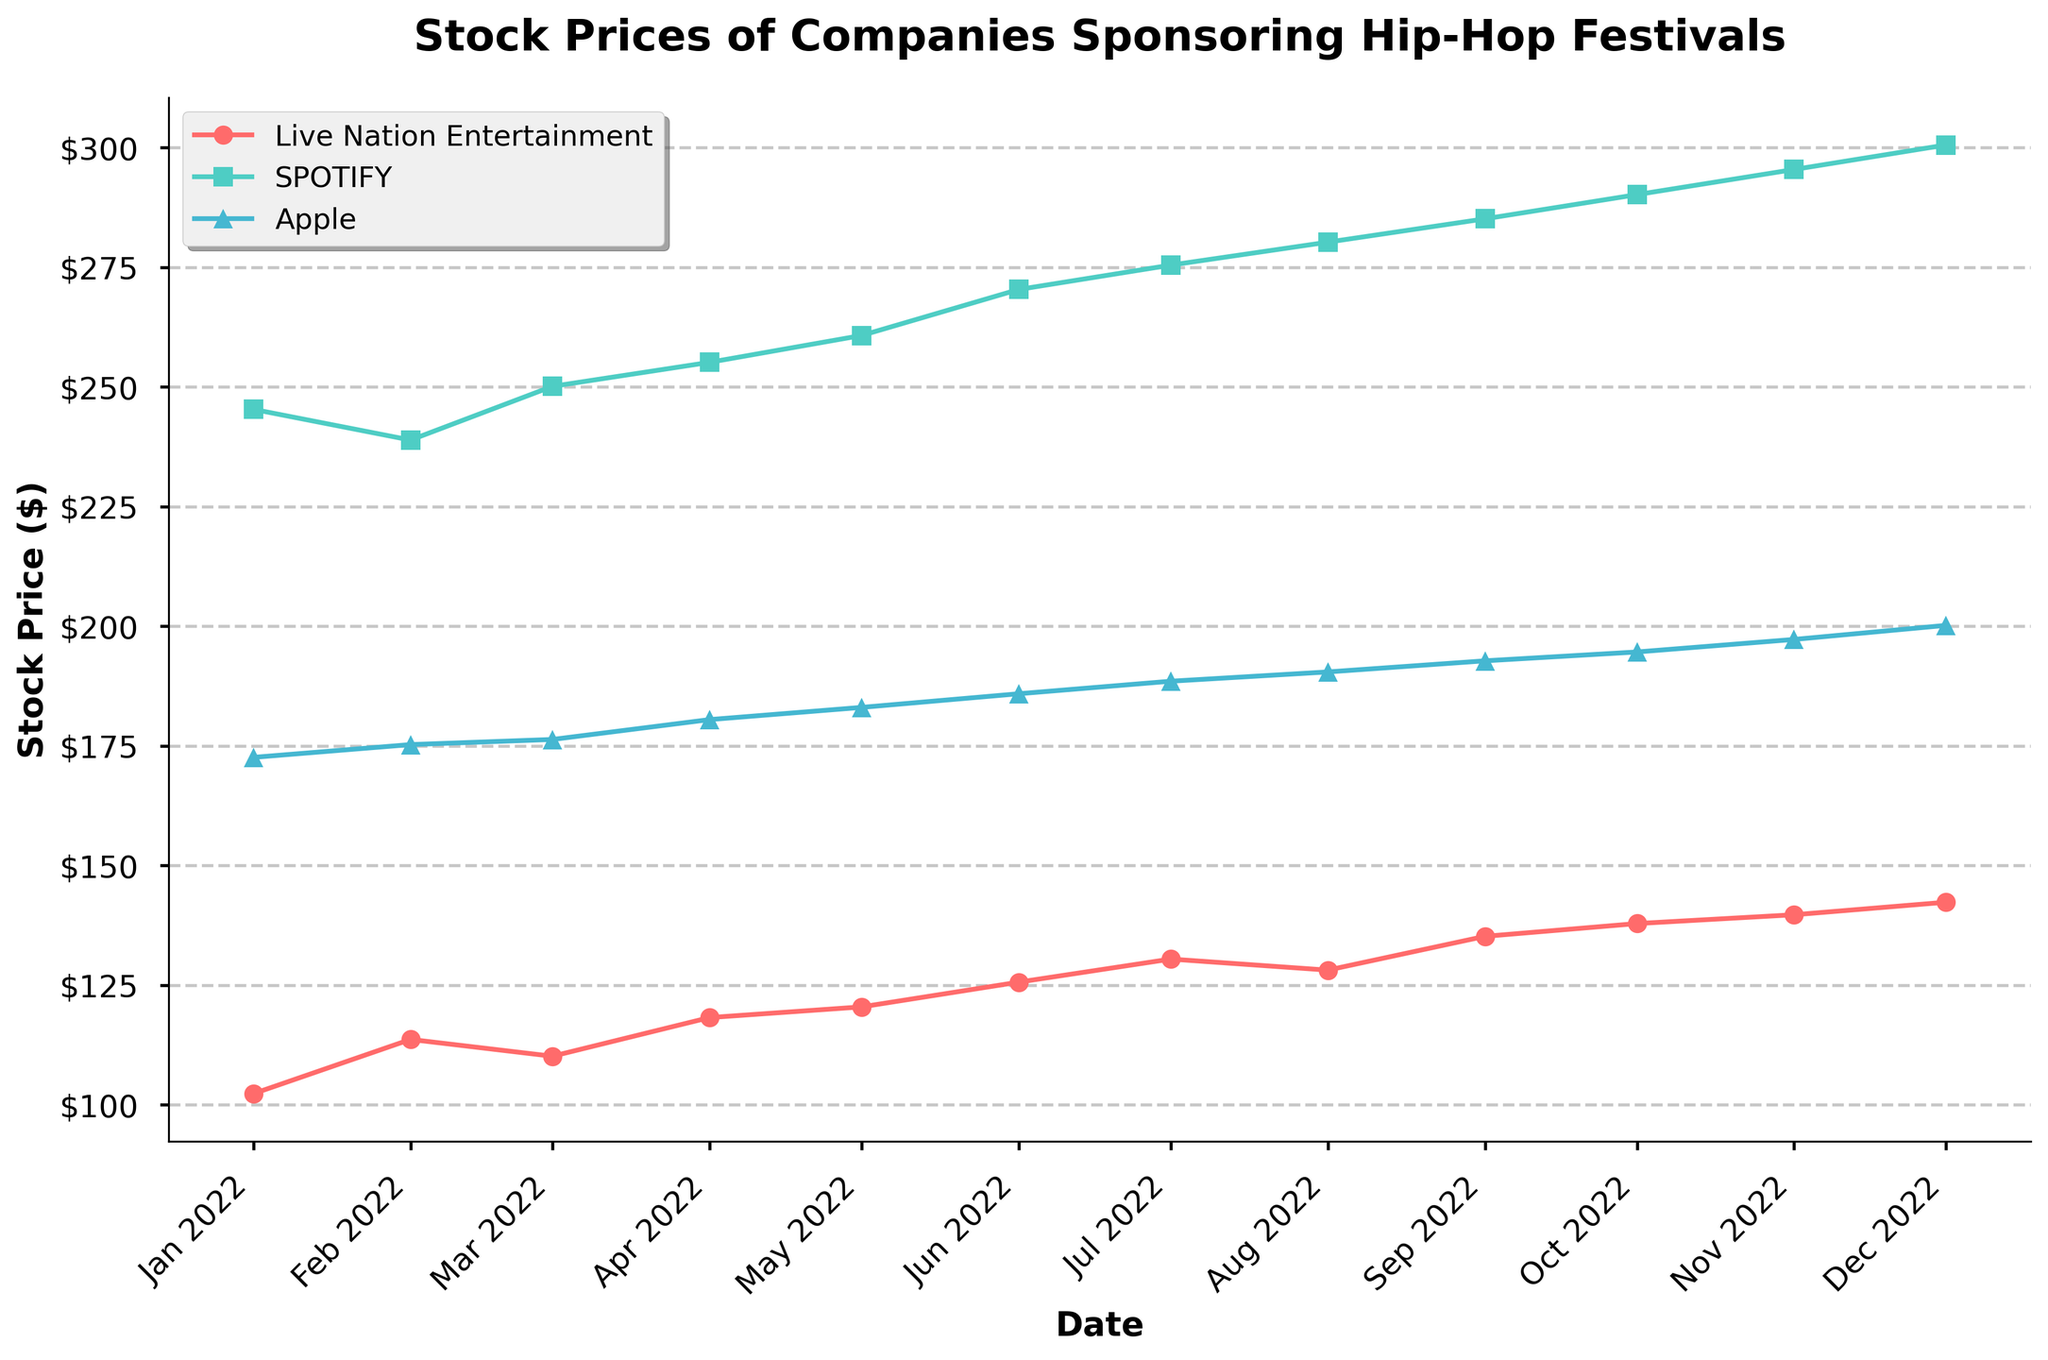What is the title of the plot? The title of the plot is displayed at the top of the figure and provides a summary of what the figure is about. It reads "Stock Prices of Companies Sponsoring Hip-Hop Festivals".
Answer: Stock Prices of Companies Sponsoring Hip-Hop Festivals Which company had the highest stock price on December 1st, 2022? The stock prices for all companies on December 1st, 2022 are displayed on the plot. The company with the visibly highest stock price is Spotify with $300.56.
Answer: Spotify How did Live Nation Entertainment's stock price change from January 1st, 2022 to December 1st, 2022? To determine the change, look at Live Nation Entertainment's stock price at the beginning and end of the year. It started at $102.35 and increased to $142.35. The change is $142.35 - $102.35.
Answer: $40.00 Which company showed the most consistent upward trend in stock prices throughout the year? By visually inspecting the plot for each company's stock prices over time, Apple shows the most consistent and steady upward trend without major fluctuations.
Answer: Apple What is the average stock price of Spotify over the entire year? Sum all Spotify's monthly stock prices and divide by the number of months (12). Calculation: (245.32 + 238.90 + 250.12 + 255.14 + 260.75 + 270.36 + 275.45 + 280.25 + 285.12 + 290.18 + 295.43 + 300.56) / 12 = 270.455
Answer: 270.46 During which month did Apple see the highest monthly increase in stock price? To determine this, compare the stock price for Apple month-to-month and find the largest increase. April saw the highest increase from $176.35 to $180.50 ($4.15 increase).
Answer: April Compare the stock price trend for Spotify and Live Nation Entertainment from January 1st, 2022 to December 1st, 2022. Which company had a larger overall increase? Calculate the net increase for each: Spotify's stock price increased from $245.32 to $300.56 (an increase of $55.24), while Live Nation Entertainment's stock price increased from $102.35 to $142.35 (an increase of $40.00). Spotify had the larger increase.
Answer: Spotify What was the stock price of Apple on July 1st, 2022? Look at the stock price of Apple on the figure for the date July 1st, 2022, which is labeled as $188.52.
Answer: $188.52 Which company's stock price increased the most between August 1st, 2022 and September 1st, 2022? By observing the stock prices between these two dates, Live Nation Entertainment's stock price increased the most from $128.16 to $135.22, a difference of $7.06.
Answer: Live Nation Entertainment 